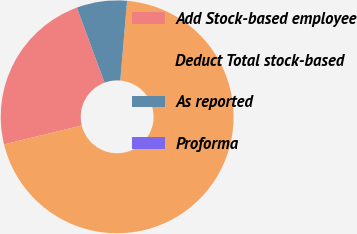<chart> <loc_0><loc_0><loc_500><loc_500><pie_chart><fcel>Add Stock-based employee<fcel>Deduct Total stock-based<fcel>As reported<fcel>Proforma<nl><fcel>23.19%<fcel>69.83%<fcel>6.98%<fcel>0.0%<nl></chart> 